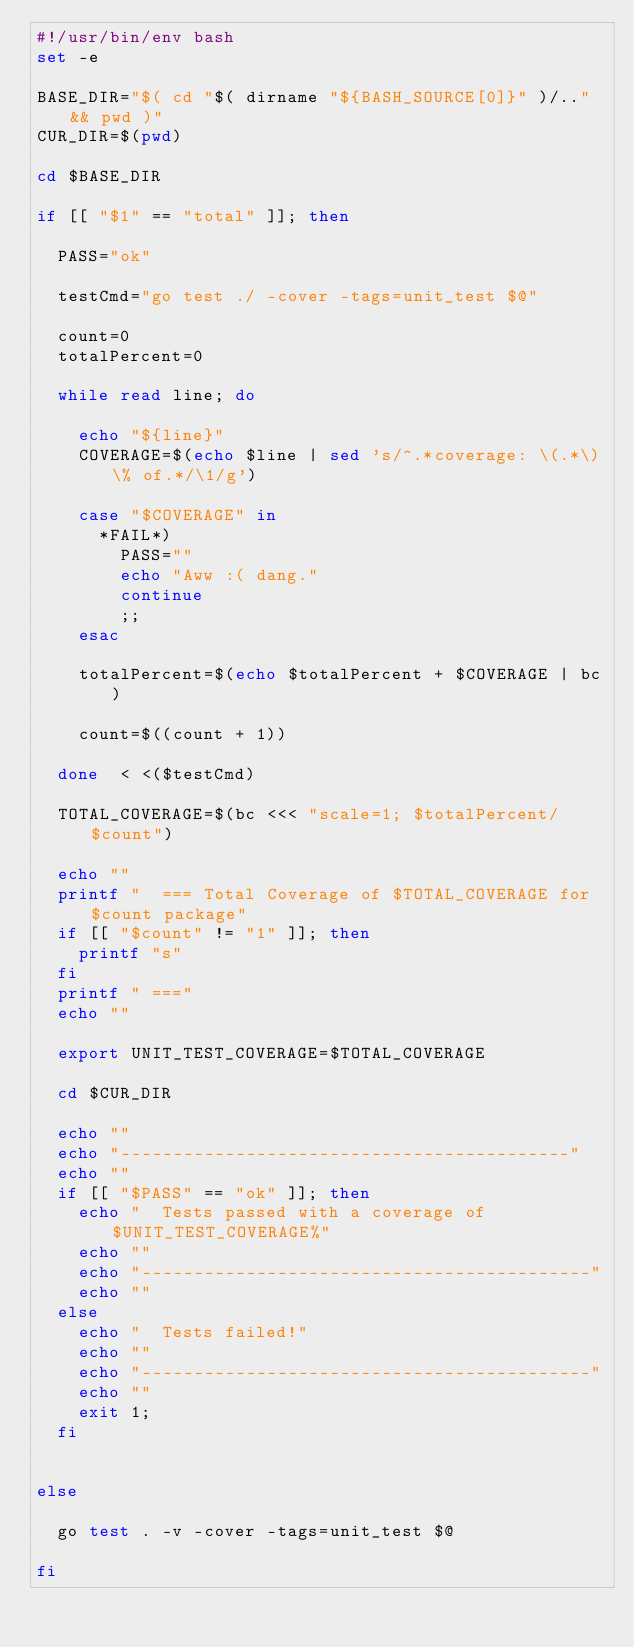Convert code to text. <code><loc_0><loc_0><loc_500><loc_500><_Bash_>#!/usr/bin/env bash
set -e

BASE_DIR="$( cd "$( dirname "${BASH_SOURCE[0]}" )/.." && pwd )"
CUR_DIR=$(pwd)

cd $BASE_DIR

if [[ "$1" == "total" ]]; then

  PASS="ok"

  testCmd="go test ./ -cover -tags=unit_test $@"

  count=0
  totalPercent=0

  while read line; do  

    echo "${line}"
    COVERAGE=$(echo $line | sed 's/^.*coverage: \(.*\)\% of.*/\1/g')

    case "$COVERAGE" in 
      *FAIL*)
        PASS=""
        echo "Aww :( dang."
        continue
        ;;
    esac

    totalPercent=$(echo $totalPercent + $COVERAGE | bc)

    count=$((count + 1))

  done  < <($testCmd)

  TOTAL_COVERAGE=$(bc <<< "scale=1; $totalPercent/$count")

  echo ""
  printf "  === Total Coverage of $TOTAL_COVERAGE for $count package"
  if [[ "$count" != "1" ]]; then 
    printf "s"
  fi
  printf " ==="
  echo ""

  export UNIT_TEST_COVERAGE=$TOTAL_COVERAGE

  cd $CUR_DIR

  echo ""
  echo "-------------------------------------------"
  echo ""
  if [[ "$PASS" == "ok" ]]; then
    echo "  Tests passed with a coverage of $UNIT_TEST_COVERAGE%"
    echo ""
    echo "-------------------------------------------"
    echo ""
  else
    echo "  Tests failed!"
    echo ""
    echo "-------------------------------------------"
    echo ""
    exit 1;
  fi

  
else 

  go test . -v -cover -tags=unit_test $@

fi
</code> 